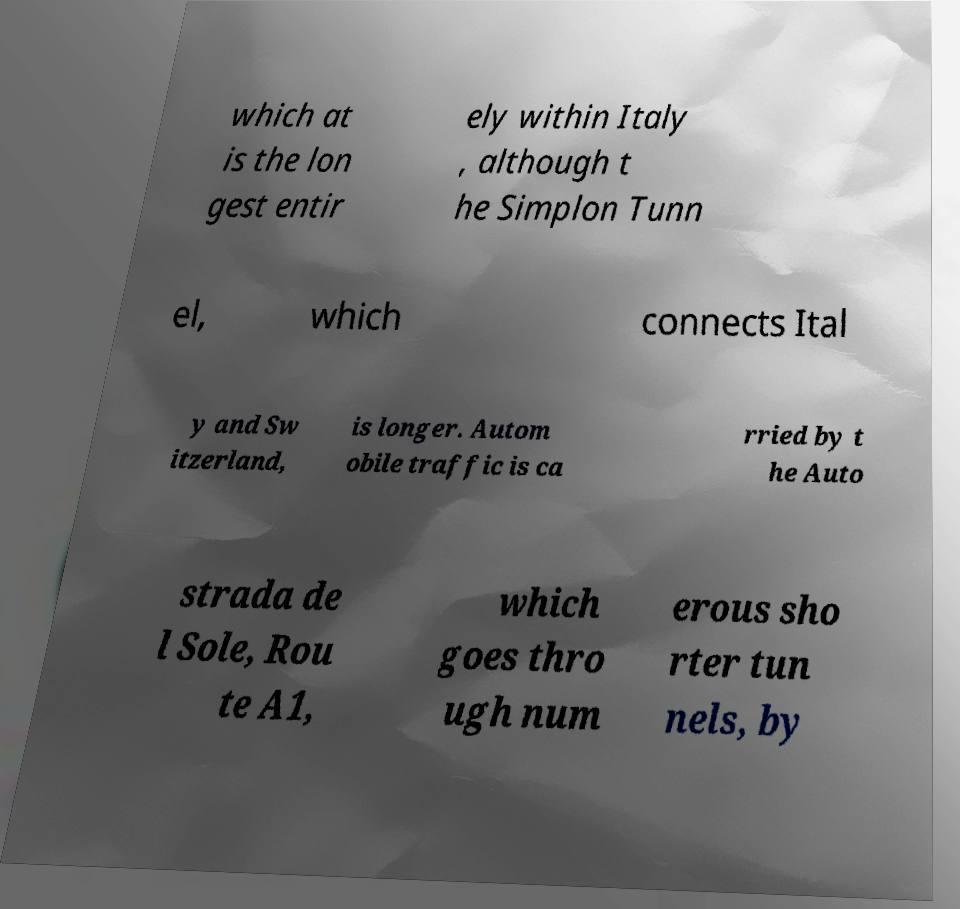Please identify and transcribe the text found in this image. which at is the lon gest entir ely within Italy , although t he Simplon Tunn el, which connects Ital y and Sw itzerland, is longer. Autom obile traffic is ca rried by t he Auto strada de l Sole, Rou te A1, which goes thro ugh num erous sho rter tun nels, by 